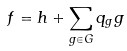Convert formula to latex. <formula><loc_0><loc_0><loc_500><loc_500>f = h + \sum _ { g \in G } q _ { g } g</formula> 